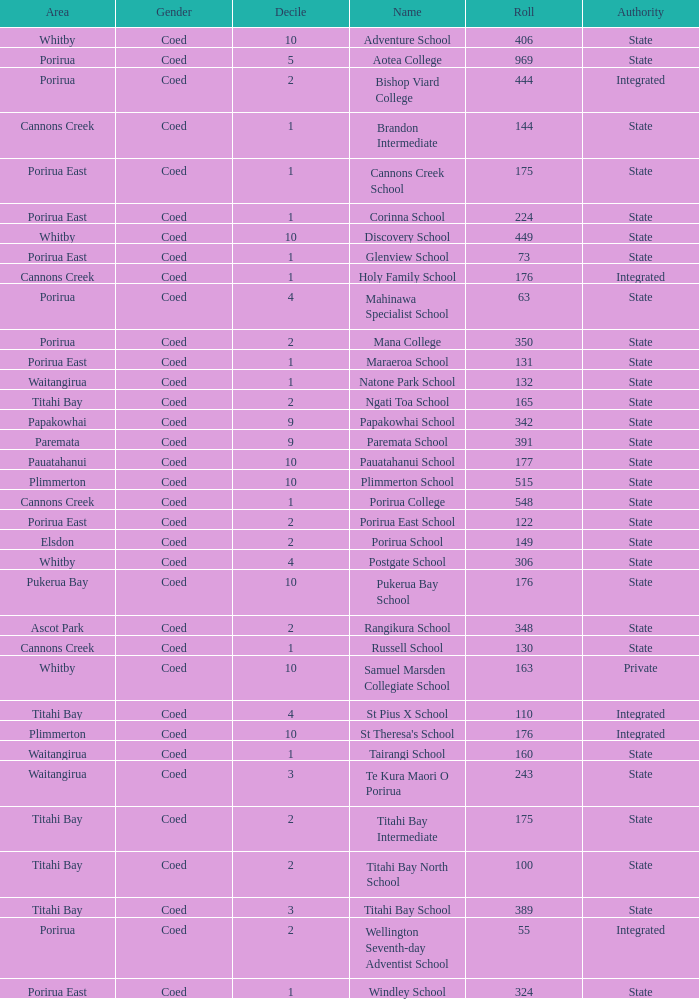What was the decile of Samuel Marsden Collegiate School in Whitby, when it had a roll higher than 163? 0.0. 